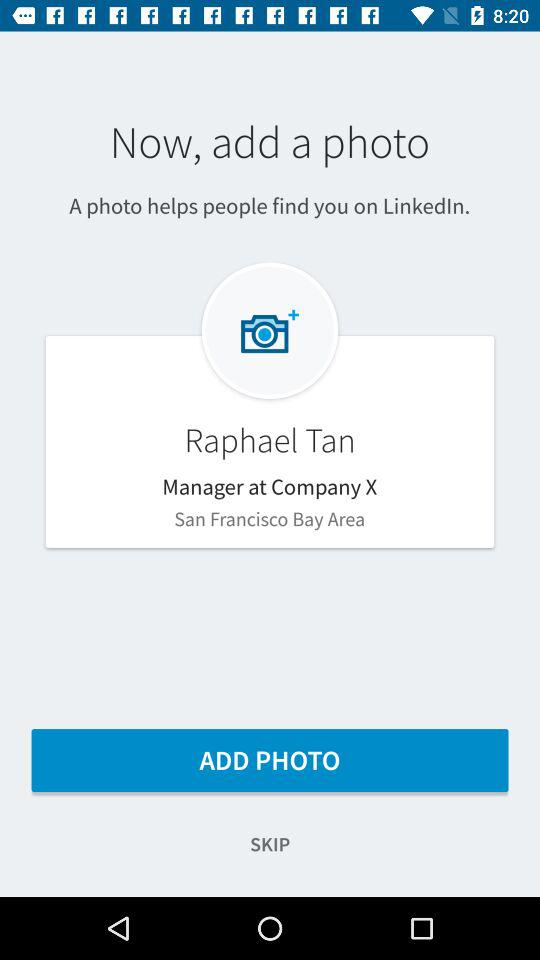What is the given designation? The given designation is manager. 